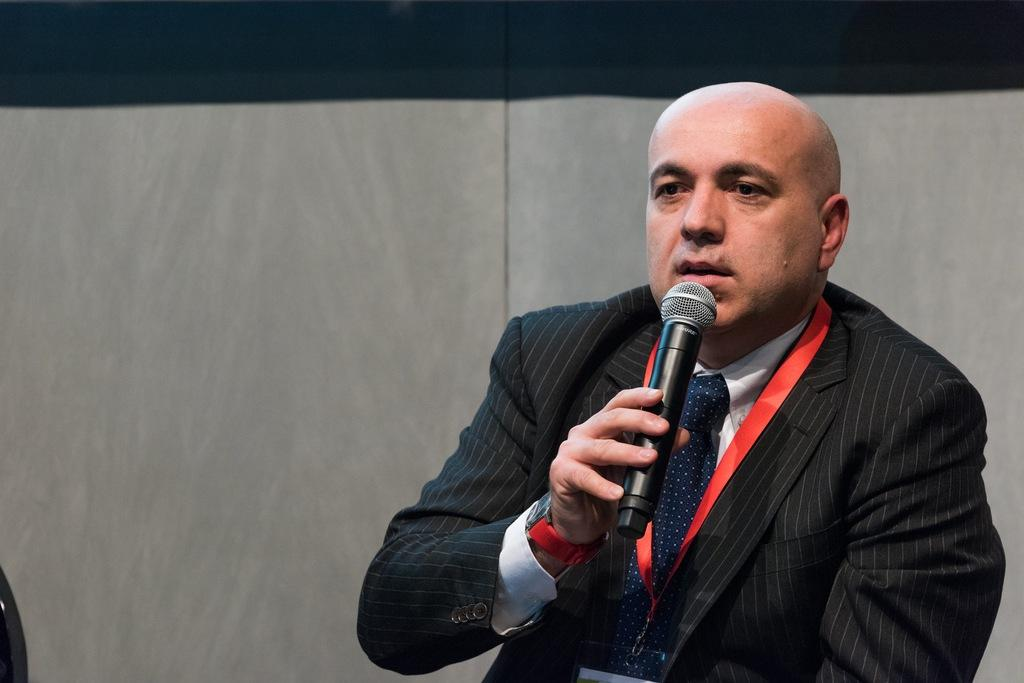What is the main subject of the image? The main subject of the image is a man. What is the man wearing in the image? The man is wearing a black blazer. What object is the man holding in the image? The man is holding a microphone. What can be seen in the background of the image? There is a wall in the background of the image. Can you see a ship in the image? There is no ship present in the image. What type of winter clothing is the man wearing in the image? The man is not wearing any winter clothing in the image, as he is wearing a black blazer. 